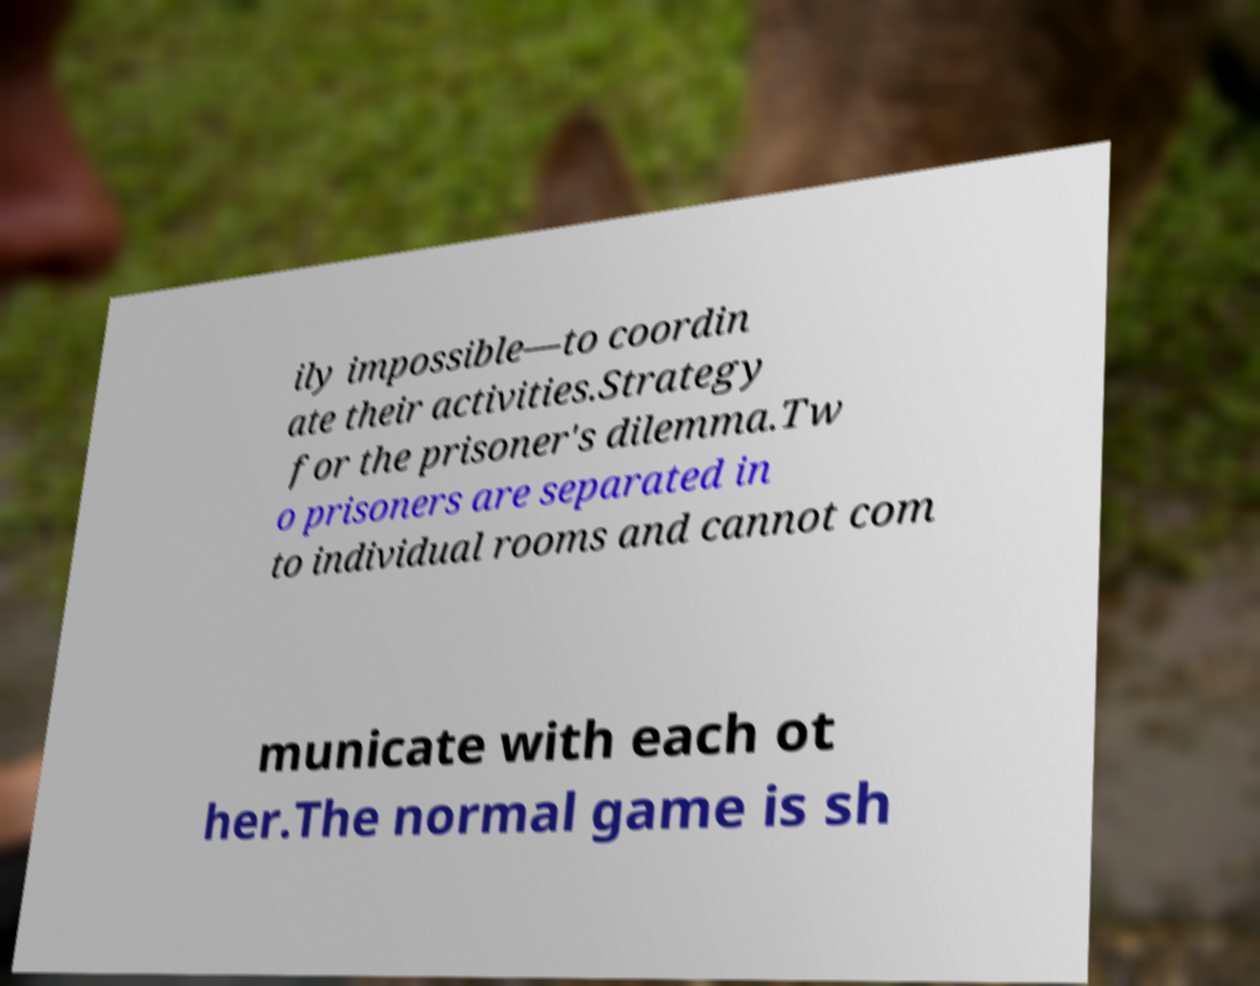There's text embedded in this image that I need extracted. Can you transcribe it verbatim? ily impossible—to coordin ate their activities.Strategy for the prisoner's dilemma.Tw o prisoners are separated in to individual rooms and cannot com municate with each ot her.The normal game is sh 